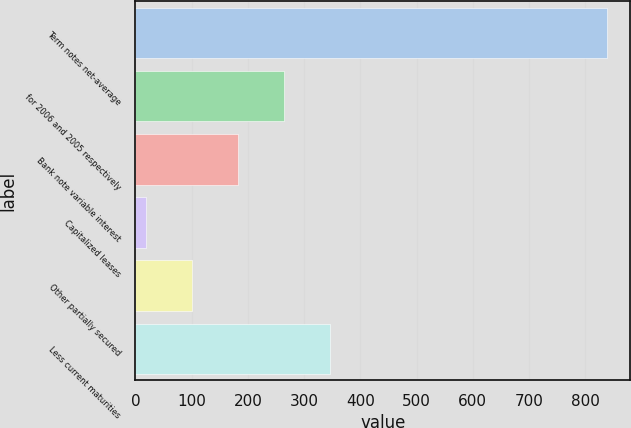Convert chart. <chart><loc_0><loc_0><loc_500><loc_500><bar_chart><fcel>Term notes net-average<fcel>for 2006 and 2005 respectively<fcel>Bank note variable interest<fcel>Capitalized leases<fcel>Other partially secured<fcel>Less current maturities<nl><fcel>838.4<fcel>264.47<fcel>182.48<fcel>18.5<fcel>100.49<fcel>346.46<nl></chart> 